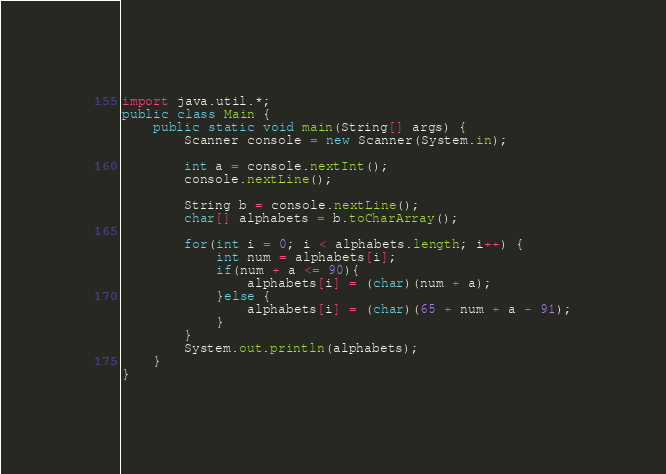<code> <loc_0><loc_0><loc_500><loc_500><_Java_>import java.util.*;
public class Main {
    public static void main(String[] args) {
        Scanner console = new Scanner(System.in);

        int a = console.nextInt();
        console.nextLine();

        String b = console.nextLine();
        char[] alphabets = b.toCharArray();

        for(int i = 0; i < alphabets.length; i++) {
            int num = alphabets[i];
            if(num + a <= 90){
                alphabets[i] = (char)(num + a);
            }else {
                alphabets[i] = (char)(65 + num + a - 91);
            }
        }
        System.out.println(alphabets);
    }
}</code> 